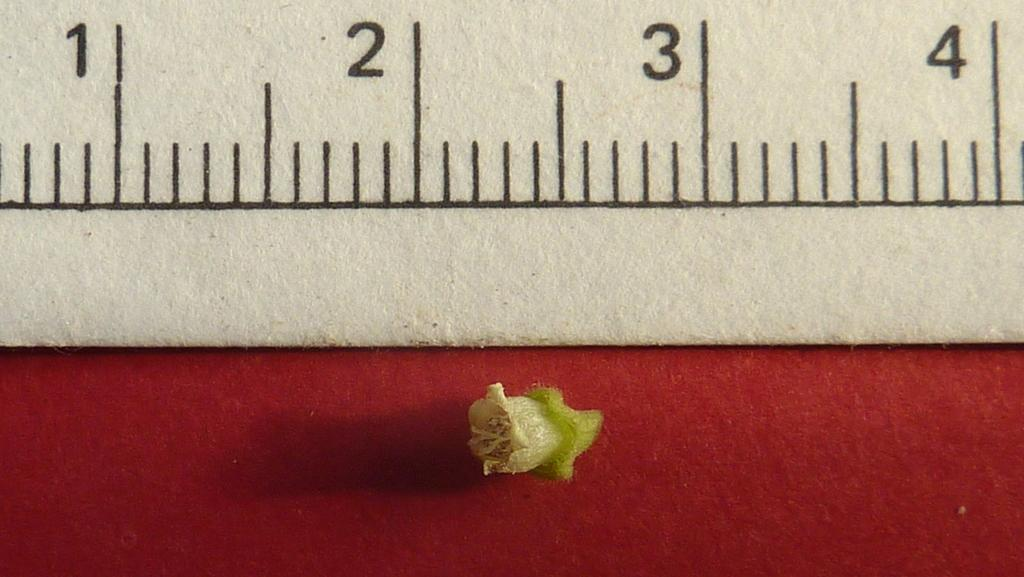<image>
Give a short and clear explanation of the subsequent image. the number 1 is on a ruler that is in front of red 